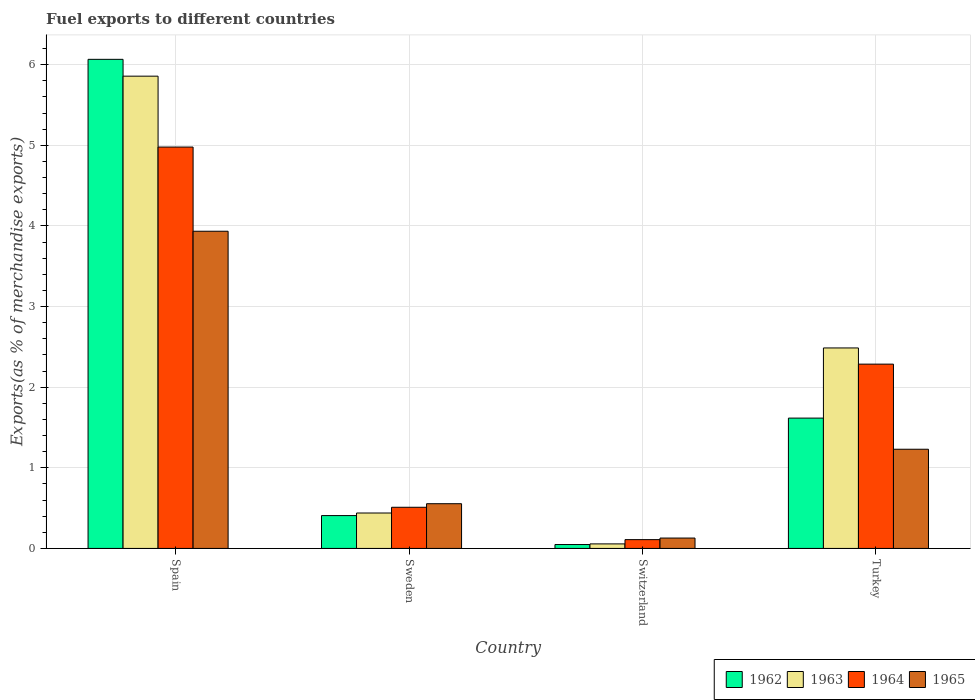Are the number of bars per tick equal to the number of legend labels?
Your response must be concise. Yes. Are the number of bars on each tick of the X-axis equal?
Your answer should be very brief. Yes. What is the percentage of exports to different countries in 1962 in Switzerland?
Your response must be concise. 0.05. Across all countries, what is the maximum percentage of exports to different countries in 1964?
Provide a short and direct response. 4.98. Across all countries, what is the minimum percentage of exports to different countries in 1963?
Your response must be concise. 0.06. In which country was the percentage of exports to different countries in 1963 minimum?
Keep it short and to the point. Switzerland. What is the total percentage of exports to different countries in 1962 in the graph?
Offer a terse response. 8.14. What is the difference between the percentage of exports to different countries in 1964 in Sweden and that in Turkey?
Provide a short and direct response. -1.78. What is the difference between the percentage of exports to different countries in 1962 in Sweden and the percentage of exports to different countries in 1965 in Switzerland?
Make the answer very short. 0.28. What is the average percentage of exports to different countries in 1963 per country?
Your answer should be very brief. 2.21. What is the difference between the percentage of exports to different countries of/in 1963 and percentage of exports to different countries of/in 1962 in Turkey?
Keep it short and to the point. 0.87. What is the ratio of the percentage of exports to different countries in 1963 in Spain to that in Sweden?
Give a very brief answer. 13.33. Is the percentage of exports to different countries in 1965 in Spain less than that in Sweden?
Ensure brevity in your answer.  No. Is the difference between the percentage of exports to different countries in 1963 in Spain and Switzerland greater than the difference between the percentage of exports to different countries in 1962 in Spain and Switzerland?
Offer a terse response. No. What is the difference between the highest and the second highest percentage of exports to different countries in 1962?
Your response must be concise. -1.21. What is the difference between the highest and the lowest percentage of exports to different countries in 1962?
Offer a terse response. 6.02. In how many countries, is the percentage of exports to different countries in 1964 greater than the average percentage of exports to different countries in 1964 taken over all countries?
Offer a very short reply. 2. Is it the case that in every country, the sum of the percentage of exports to different countries in 1962 and percentage of exports to different countries in 1963 is greater than the sum of percentage of exports to different countries in 1964 and percentage of exports to different countries in 1965?
Give a very brief answer. No. What does the 4th bar from the right in Switzerland represents?
Offer a very short reply. 1962. Is it the case that in every country, the sum of the percentage of exports to different countries in 1963 and percentage of exports to different countries in 1962 is greater than the percentage of exports to different countries in 1965?
Offer a terse response. No. Are all the bars in the graph horizontal?
Offer a very short reply. No. Does the graph contain any zero values?
Your response must be concise. No. How many legend labels are there?
Your answer should be compact. 4. What is the title of the graph?
Provide a short and direct response. Fuel exports to different countries. What is the label or title of the X-axis?
Your answer should be compact. Country. What is the label or title of the Y-axis?
Make the answer very short. Exports(as % of merchandise exports). What is the Exports(as % of merchandise exports) of 1962 in Spain?
Your answer should be very brief. 6.07. What is the Exports(as % of merchandise exports) of 1963 in Spain?
Keep it short and to the point. 5.86. What is the Exports(as % of merchandise exports) in 1964 in Spain?
Your response must be concise. 4.98. What is the Exports(as % of merchandise exports) in 1965 in Spain?
Offer a very short reply. 3.93. What is the Exports(as % of merchandise exports) of 1962 in Sweden?
Your answer should be compact. 0.41. What is the Exports(as % of merchandise exports) of 1963 in Sweden?
Give a very brief answer. 0.44. What is the Exports(as % of merchandise exports) of 1964 in Sweden?
Your response must be concise. 0.51. What is the Exports(as % of merchandise exports) of 1965 in Sweden?
Your answer should be compact. 0.55. What is the Exports(as % of merchandise exports) of 1962 in Switzerland?
Your response must be concise. 0.05. What is the Exports(as % of merchandise exports) of 1963 in Switzerland?
Your answer should be very brief. 0.06. What is the Exports(as % of merchandise exports) in 1964 in Switzerland?
Ensure brevity in your answer.  0.11. What is the Exports(as % of merchandise exports) of 1965 in Switzerland?
Your answer should be compact. 0.13. What is the Exports(as % of merchandise exports) of 1962 in Turkey?
Make the answer very short. 1.62. What is the Exports(as % of merchandise exports) in 1963 in Turkey?
Your response must be concise. 2.49. What is the Exports(as % of merchandise exports) in 1964 in Turkey?
Offer a terse response. 2.29. What is the Exports(as % of merchandise exports) of 1965 in Turkey?
Provide a short and direct response. 1.23. Across all countries, what is the maximum Exports(as % of merchandise exports) in 1962?
Give a very brief answer. 6.07. Across all countries, what is the maximum Exports(as % of merchandise exports) of 1963?
Keep it short and to the point. 5.86. Across all countries, what is the maximum Exports(as % of merchandise exports) in 1964?
Your response must be concise. 4.98. Across all countries, what is the maximum Exports(as % of merchandise exports) of 1965?
Your response must be concise. 3.93. Across all countries, what is the minimum Exports(as % of merchandise exports) of 1962?
Your answer should be compact. 0.05. Across all countries, what is the minimum Exports(as % of merchandise exports) in 1963?
Keep it short and to the point. 0.06. Across all countries, what is the minimum Exports(as % of merchandise exports) in 1964?
Make the answer very short. 0.11. Across all countries, what is the minimum Exports(as % of merchandise exports) in 1965?
Provide a short and direct response. 0.13. What is the total Exports(as % of merchandise exports) of 1962 in the graph?
Your response must be concise. 8.14. What is the total Exports(as % of merchandise exports) in 1963 in the graph?
Make the answer very short. 8.84. What is the total Exports(as % of merchandise exports) in 1964 in the graph?
Give a very brief answer. 7.88. What is the total Exports(as % of merchandise exports) of 1965 in the graph?
Give a very brief answer. 5.85. What is the difference between the Exports(as % of merchandise exports) in 1962 in Spain and that in Sweden?
Your answer should be very brief. 5.66. What is the difference between the Exports(as % of merchandise exports) of 1963 in Spain and that in Sweden?
Your response must be concise. 5.42. What is the difference between the Exports(as % of merchandise exports) of 1964 in Spain and that in Sweden?
Your answer should be very brief. 4.47. What is the difference between the Exports(as % of merchandise exports) of 1965 in Spain and that in Sweden?
Your answer should be very brief. 3.38. What is the difference between the Exports(as % of merchandise exports) of 1962 in Spain and that in Switzerland?
Keep it short and to the point. 6.02. What is the difference between the Exports(as % of merchandise exports) in 1963 in Spain and that in Switzerland?
Your answer should be compact. 5.8. What is the difference between the Exports(as % of merchandise exports) in 1964 in Spain and that in Switzerland?
Give a very brief answer. 4.87. What is the difference between the Exports(as % of merchandise exports) in 1965 in Spain and that in Switzerland?
Give a very brief answer. 3.81. What is the difference between the Exports(as % of merchandise exports) in 1962 in Spain and that in Turkey?
Your response must be concise. 4.45. What is the difference between the Exports(as % of merchandise exports) of 1963 in Spain and that in Turkey?
Provide a succinct answer. 3.37. What is the difference between the Exports(as % of merchandise exports) of 1964 in Spain and that in Turkey?
Offer a very short reply. 2.69. What is the difference between the Exports(as % of merchandise exports) of 1965 in Spain and that in Turkey?
Keep it short and to the point. 2.7. What is the difference between the Exports(as % of merchandise exports) in 1962 in Sweden and that in Switzerland?
Make the answer very short. 0.36. What is the difference between the Exports(as % of merchandise exports) in 1963 in Sweden and that in Switzerland?
Your answer should be very brief. 0.38. What is the difference between the Exports(as % of merchandise exports) in 1964 in Sweden and that in Switzerland?
Make the answer very short. 0.4. What is the difference between the Exports(as % of merchandise exports) in 1965 in Sweden and that in Switzerland?
Give a very brief answer. 0.43. What is the difference between the Exports(as % of merchandise exports) in 1962 in Sweden and that in Turkey?
Keep it short and to the point. -1.21. What is the difference between the Exports(as % of merchandise exports) of 1963 in Sweden and that in Turkey?
Ensure brevity in your answer.  -2.05. What is the difference between the Exports(as % of merchandise exports) in 1964 in Sweden and that in Turkey?
Ensure brevity in your answer.  -1.78. What is the difference between the Exports(as % of merchandise exports) in 1965 in Sweden and that in Turkey?
Offer a terse response. -0.68. What is the difference between the Exports(as % of merchandise exports) in 1962 in Switzerland and that in Turkey?
Your response must be concise. -1.57. What is the difference between the Exports(as % of merchandise exports) of 1963 in Switzerland and that in Turkey?
Provide a short and direct response. -2.43. What is the difference between the Exports(as % of merchandise exports) in 1964 in Switzerland and that in Turkey?
Make the answer very short. -2.18. What is the difference between the Exports(as % of merchandise exports) of 1965 in Switzerland and that in Turkey?
Provide a succinct answer. -1.1. What is the difference between the Exports(as % of merchandise exports) in 1962 in Spain and the Exports(as % of merchandise exports) in 1963 in Sweden?
Provide a succinct answer. 5.63. What is the difference between the Exports(as % of merchandise exports) in 1962 in Spain and the Exports(as % of merchandise exports) in 1964 in Sweden?
Your answer should be very brief. 5.56. What is the difference between the Exports(as % of merchandise exports) in 1962 in Spain and the Exports(as % of merchandise exports) in 1965 in Sweden?
Give a very brief answer. 5.51. What is the difference between the Exports(as % of merchandise exports) of 1963 in Spain and the Exports(as % of merchandise exports) of 1964 in Sweden?
Give a very brief answer. 5.35. What is the difference between the Exports(as % of merchandise exports) of 1963 in Spain and the Exports(as % of merchandise exports) of 1965 in Sweden?
Give a very brief answer. 5.3. What is the difference between the Exports(as % of merchandise exports) of 1964 in Spain and the Exports(as % of merchandise exports) of 1965 in Sweden?
Your answer should be very brief. 4.42. What is the difference between the Exports(as % of merchandise exports) of 1962 in Spain and the Exports(as % of merchandise exports) of 1963 in Switzerland?
Make the answer very short. 6.01. What is the difference between the Exports(as % of merchandise exports) in 1962 in Spain and the Exports(as % of merchandise exports) in 1964 in Switzerland?
Provide a succinct answer. 5.96. What is the difference between the Exports(as % of merchandise exports) in 1962 in Spain and the Exports(as % of merchandise exports) in 1965 in Switzerland?
Make the answer very short. 5.94. What is the difference between the Exports(as % of merchandise exports) of 1963 in Spain and the Exports(as % of merchandise exports) of 1964 in Switzerland?
Your answer should be compact. 5.75. What is the difference between the Exports(as % of merchandise exports) of 1963 in Spain and the Exports(as % of merchandise exports) of 1965 in Switzerland?
Offer a very short reply. 5.73. What is the difference between the Exports(as % of merchandise exports) in 1964 in Spain and the Exports(as % of merchandise exports) in 1965 in Switzerland?
Give a very brief answer. 4.85. What is the difference between the Exports(as % of merchandise exports) of 1962 in Spain and the Exports(as % of merchandise exports) of 1963 in Turkey?
Offer a terse response. 3.58. What is the difference between the Exports(as % of merchandise exports) in 1962 in Spain and the Exports(as % of merchandise exports) in 1964 in Turkey?
Provide a short and direct response. 3.78. What is the difference between the Exports(as % of merchandise exports) in 1962 in Spain and the Exports(as % of merchandise exports) in 1965 in Turkey?
Your answer should be compact. 4.84. What is the difference between the Exports(as % of merchandise exports) of 1963 in Spain and the Exports(as % of merchandise exports) of 1964 in Turkey?
Give a very brief answer. 3.57. What is the difference between the Exports(as % of merchandise exports) in 1963 in Spain and the Exports(as % of merchandise exports) in 1965 in Turkey?
Give a very brief answer. 4.63. What is the difference between the Exports(as % of merchandise exports) in 1964 in Spain and the Exports(as % of merchandise exports) in 1965 in Turkey?
Your answer should be very brief. 3.75. What is the difference between the Exports(as % of merchandise exports) of 1962 in Sweden and the Exports(as % of merchandise exports) of 1963 in Switzerland?
Your answer should be very brief. 0.35. What is the difference between the Exports(as % of merchandise exports) in 1962 in Sweden and the Exports(as % of merchandise exports) in 1964 in Switzerland?
Your response must be concise. 0.3. What is the difference between the Exports(as % of merchandise exports) in 1962 in Sweden and the Exports(as % of merchandise exports) in 1965 in Switzerland?
Offer a very short reply. 0.28. What is the difference between the Exports(as % of merchandise exports) of 1963 in Sweden and the Exports(as % of merchandise exports) of 1964 in Switzerland?
Give a very brief answer. 0.33. What is the difference between the Exports(as % of merchandise exports) of 1963 in Sweden and the Exports(as % of merchandise exports) of 1965 in Switzerland?
Offer a very short reply. 0.31. What is the difference between the Exports(as % of merchandise exports) in 1964 in Sweden and the Exports(as % of merchandise exports) in 1965 in Switzerland?
Offer a terse response. 0.38. What is the difference between the Exports(as % of merchandise exports) of 1962 in Sweden and the Exports(as % of merchandise exports) of 1963 in Turkey?
Your answer should be very brief. -2.08. What is the difference between the Exports(as % of merchandise exports) in 1962 in Sweden and the Exports(as % of merchandise exports) in 1964 in Turkey?
Your answer should be compact. -1.88. What is the difference between the Exports(as % of merchandise exports) in 1962 in Sweden and the Exports(as % of merchandise exports) in 1965 in Turkey?
Offer a very short reply. -0.82. What is the difference between the Exports(as % of merchandise exports) in 1963 in Sweden and the Exports(as % of merchandise exports) in 1964 in Turkey?
Offer a terse response. -1.85. What is the difference between the Exports(as % of merchandise exports) of 1963 in Sweden and the Exports(as % of merchandise exports) of 1965 in Turkey?
Make the answer very short. -0.79. What is the difference between the Exports(as % of merchandise exports) in 1964 in Sweden and the Exports(as % of merchandise exports) in 1965 in Turkey?
Make the answer very short. -0.72. What is the difference between the Exports(as % of merchandise exports) in 1962 in Switzerland and the Exports(as % of merchandise exports) in 1963 in Turkey?
Your answer should be very brief. -2.44. What is the difference between the Exports(as % of merchandise exports) in 1962 in Switzerland and the Exports(as % of merchandise exports) in 1964 in Turkey?
Provide a short and direct response. -2.24. What is the difference between the Exports(as % of merchandise exports) of 1962 in Switzerland and the Exports(as % of merchandise exports) of 1965 in Turkey?
Ensure brevity in your answer.  -1.18. What is the difference between the Exports(as % of merchandise exports) in 1963 in Switzerland and the Exports(as % of merchandise exports) in 1964 in Turkey?
Make the answer very short. -2.23. What is the difference between the Exports(as % of merchandise exports) of 1963 in Switzerland and the Exports(as % of merchandise exports) of 1965 in Turkey?
Keep it short and to the point. -1.17. What is the difference between the Exports(as % of merchandise exports) in 1964 in Switzerland and the Exports(as % of merchandise exports) in 1965 in Turkey?
Make the answer very short. -1.12. What is the average Exports(as % of merchandise exports) of 1962 per country?
Your response must be concise. 2.03. What is the average Exports(as % of merchandise exports) in 1963 per country?
Provide a succinct answer. 2.21. What is the average Exports(as % of merchandise exports) of 1964 per country?
Your response must be concise. 1.97. What is the average Exports(as % of merchandise exports) of 1965 per country?
Ensure brevity in your answer.  1.46. What is the difference between the Exports(as % of merchandise exports) in 1962 and Exports(as % of merchandise exports) in 1963 in Spain?
Your answer should be very brief. 0.21. What is the difference between the Exports(as % of merchandise exports) in 1962 and Exports(as % of merchandise exports) in 1964 in Spain?
Offer a terse response. 1.09. What is the difference between the Exports(as % of merchandise exports) in 1962 and Exports(as % of merchandise exports) in 1965 in Spain?
Make the answer very short. 2.13. What is the difference between the Exports(as % of merchandise exports) of 1963 and Exports(as % of merchandise exports) of 1964 in Spain?
Provide a succinct answer. 0.88. What is the difference between the Exports(as % of merchandise exports) in 1963 and Exports(as % of merchandise exports) in 1965 in Spain?
Make the answer very short. 1.92. What is the difference between the Exports(as % of merchandise exports) in 1964 and Exports(as % of merchandise exports) in 1965 in Spain?
Offer a terse response. 1.04. What is the difference between the Exports(as % of merchandise exports) in 1962 and Exports(as % of merchandise exports) in 1963 in Sweden?
Give a very brief answer. -0.03. What is the difference between the Exports(as % of merchandise exports) of 1962 and Exports(as % of merchandise exports) of 1964 in Sweden?
Offer a terse response. -0.1. What is the difference between the Exports(as % of merchandise exports) of 1962 and Exports(as % of merchandise exports) of 1965 in Sweden?
Offer a terse response. -0.15. What is the difference between the Exports(as % of merchandise exports) in 1963 and Exports(as % of merchandise exports) in 1964 in Sweden?
Offer a very short reply. -0.07. What is the difference between the Exports(as % of merchandise exports) of 1963 and Exports(as % of merchandise exports) of 1965 in Sweden?
Provide a succinct answer. -0.12. What is the difference between the Exports(as % of merchandise exports) of 1964 and Exports(as % of merchandise exports) of 1965 in Sweden?
Provide a succinct answer. -0.04. What is the difference between the Exports(as % of merchandise exports) in 1962 and Exports(as % of merchandise exports) in 1963 in Switzerland?
Offer a terse response. -0.01. What is the difference between the Exports(as % of merchandise exports) of 1962 and Exports(as % of merchandise exports) of 1964 in Switzerland?
Your answer should be compact. -0.06. What is the difference between the Exports(as % of merchandise exports) in 1962 and Exports(as % of merchandise exports) in 1965 in Switzerland?
Offer a very short reply. -0.08. What is the difference between the Exports(as % of merchandise exports) in 1963 and Exports(as % of merchandise exports) in 1964 in Switzerland?
Provide a succinct answer. -0.05. What is the difference between the Exports(as % of merchandise exports) in 1963 and Exports(as % of merchandise exports) in 1965 in Switzerland?
Offer a very short reply. -0.07. What is the difference between the Exports(as % of merchandise exports) in 1964 and Exports(as % of merchandise exports) in 1965 in Switzerland?
Offer a terse response. -0.02. What is the difference between the Exports(as % of merchandise exports) of 1962 and Exports(as % of merchandise exports) of 1963 in Turkey?
Make the answer very short. -0.87. What is the difference between the Exports(as % of merchandise exports) of 1962 and Exports(as % of merchandise exports) of 1964 in Turkey?
Make the answer very short. -0.67. What is the difference between the Exports(as % of merchandise exports) of 1962 and Exports(as % of merchandise exports) of 1965 in Turkey?
Offer a very short reply. 0.39. What is the difference between the Exports(as % of merchandise exports) of 1963 and Exports(as % of merchandise exports) of 1964 in Turkey?
Provide a short and direct response. 0.2. What is the difference between the Exports(as % of merchandise exports) of 1963 and Exports(as % of merchandise exports) of 1965 in Turkey?
Keep it short and to the point. 1.26. What is the difference between the Exports(as % of merchandise exports) of 1964 and Exports(as % of merchandise exports) of 1965 in Turkey?
Keep it short and to the point. 1.06. What is the ratio of the Exports(as % of merchandise exports) of 1962 in Spain to that in Sweden?
Make the answer very short. 14.89. What is the ratio of the Exports(as % of merchandise exports) of 1963 in Spain to that in Sweden?
Your response must be concise. 13.33. What is the ratio of the Exports(as % of merchandise exports) in 1964 in Spain to that in Sweden?
Make the answer very short. 9.75. What is the ratio of the Exports(as % of merchandise exports) of 1965 in Spain to that in Sweden?
Ensure brevity in your answer.  7.09. What is the ratio of the Exports(as % of merchandise exports) in 1962 in Spain to that in Switzerland?
Your answer should be very brief. 125.74. What is the ratio of the Exports(as % of merchandise exports) in 1963 in Spain to that in Switzerland?
Your answer should be very brief. 104.12. What is the ratio of the Exports(as % of merchandise exports) of 1964 in Spain to that in Switzerland?
Give a very brief answer. 45.62. What is the ratio of the Exports(as % of merchandise exports) of 1965 in Spain to that in Switzerland?
Ensure brevity in your answer.  30.54. What is the ratio of the Exports(as % of merchandise exports) in 1962 in Spain to that in Turkey?
Your response must be concise. 3.75. What is the ratio of the Exports(as % of merchandise exports) of 1963 in Spain to that in Turkey?
Offer a very short reply. 2.36. What is the ratio of the Exports(as % of merchandise exports) of 1964 in Spain to that in Turkey?
Offer a very short reply. 2.18. What is the ratio of the Exports(as % of merchandise exports) of 1965 in Spain to that in Turkey?
Ensure brevity in your answer.  3.2. What is the ratio of the Exports(as % of merchandise exports) of 1962 in Sweden to that in Switzerland?
Give a very brief answer. 8.44. What is the ratio of the Exports(as % of merchandise exports) in 1963 in Sweden to that in Switzerland?
Keep it short and to the point. 7.81. What is the ratio of the Exports(as % of merchandise exports) of 1964 in Sweden to that in Switzerland?
Give a very brief answer. 4.68. What is the ratio of the Exports(as % of merchandise exports) in 1965 in Sweden to that in Switzerland?
Give a very brief answer. 4.31. What is the ratio of the Exports(as % of merchandise exports) in 1962 in Sweden to that in Turkey?
Offer a very short reply. 0.25. What is the ratio of the Exports(as % of merchandise exports) in 1963 in Sweden to that in Turkey?
Provide a succinct answer. 0.18. What is the ratio of the Exports(as % of merchandise exports) of 1964 in Sweden to that in Turkey?
Offer a very short reply. 0.22. What is the ratio of the Exports(as % of merchandise exports) of 1965 in Sweden to that in Turkey?
Offer a terse response. 0.45. What is the ratio of the Exports(as % of merchandise exports) of 1962 in Switzerland to that in Turkey?
Keep it short and to the point. 0.03. What is the ratio of the Exports(as % of merchandise exports) of 1963 in Switzerland to that in Turkey?
Give a very brief answer. 0.02. What is the ratio of the Exports(as % of merchandise exports) in 1964 in Switzerland to that in Turkey?
Provide a succinct answer. 0.05. What is the ratio of the Exports(as % of merchandise exports) of 1965 in Switzerland to that in Turkey?
Ensure brevity in your answer.  0.1. What is the difference between the highest and the second highest Exports(as % of merchandise exports) in 1962?
Your answer should be very brief. 4.45. What is the difference between the highest and the second highest Exports(as % of merchandise exports) in 1963?
Provide a short and direct response. 3.37. What is the difference between the highest and the second highest Exports(as % of merchandise exports) of 1964?
Keep it short and to the point. 2.69. What is the difference between the highest and the second highest Exports(as % of merchandise exports) in 1965?
Give a very brief answer. 2.7. What is the difference between the highest and the lowest Exports(as % of merchandise exports) in 1962?
Give a very brief answer. 6.02. What is the difference between the highest and the lowest Exports(as % of merchandise exports) of 1963?
Your answer should be compact. 5.8. What is the difference between the highest and the lowest Exports(as % of merchandise exports) in 1964?
Make the answer very short. 4.87. What is the difference between the highest and the lowest Exports(as % of merchandise exports) in 1965?
Offer a terse response. 3.81. 